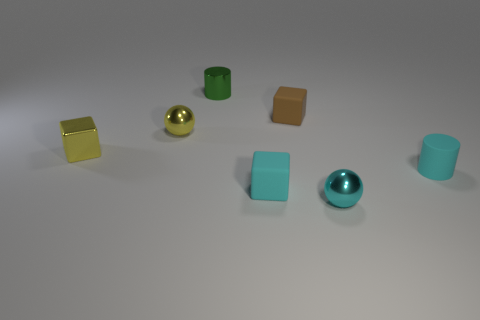Subtract all rubber blocks. How many blocks are left? 1 Subtract all yellow cubes. How many cubes are left? 2 Add 2 purple balls. How many objects exist? 9 Subtract all cubes. How many objects are left? 4 Subtract 1 spheres. How many spheres are left? 1 Add 6 matte cubes. How many matte cubes are left? 8 Add 1 small purple shiny spheres. How many small purple shiny spheres exist? 1 Subtract 0 purple spheres. How many objects are left? 7 Subtract all green cubes. Subtract all purple balls. How many cubes are left? 3 Subtract all cyan rubber cubes. Subtract all spheres. How many objects are left? 4 